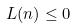Convert formula to latex. <formula><loc_0><loc_0><loc_500><loc_500>L ( n ) \leq 0</formula> 